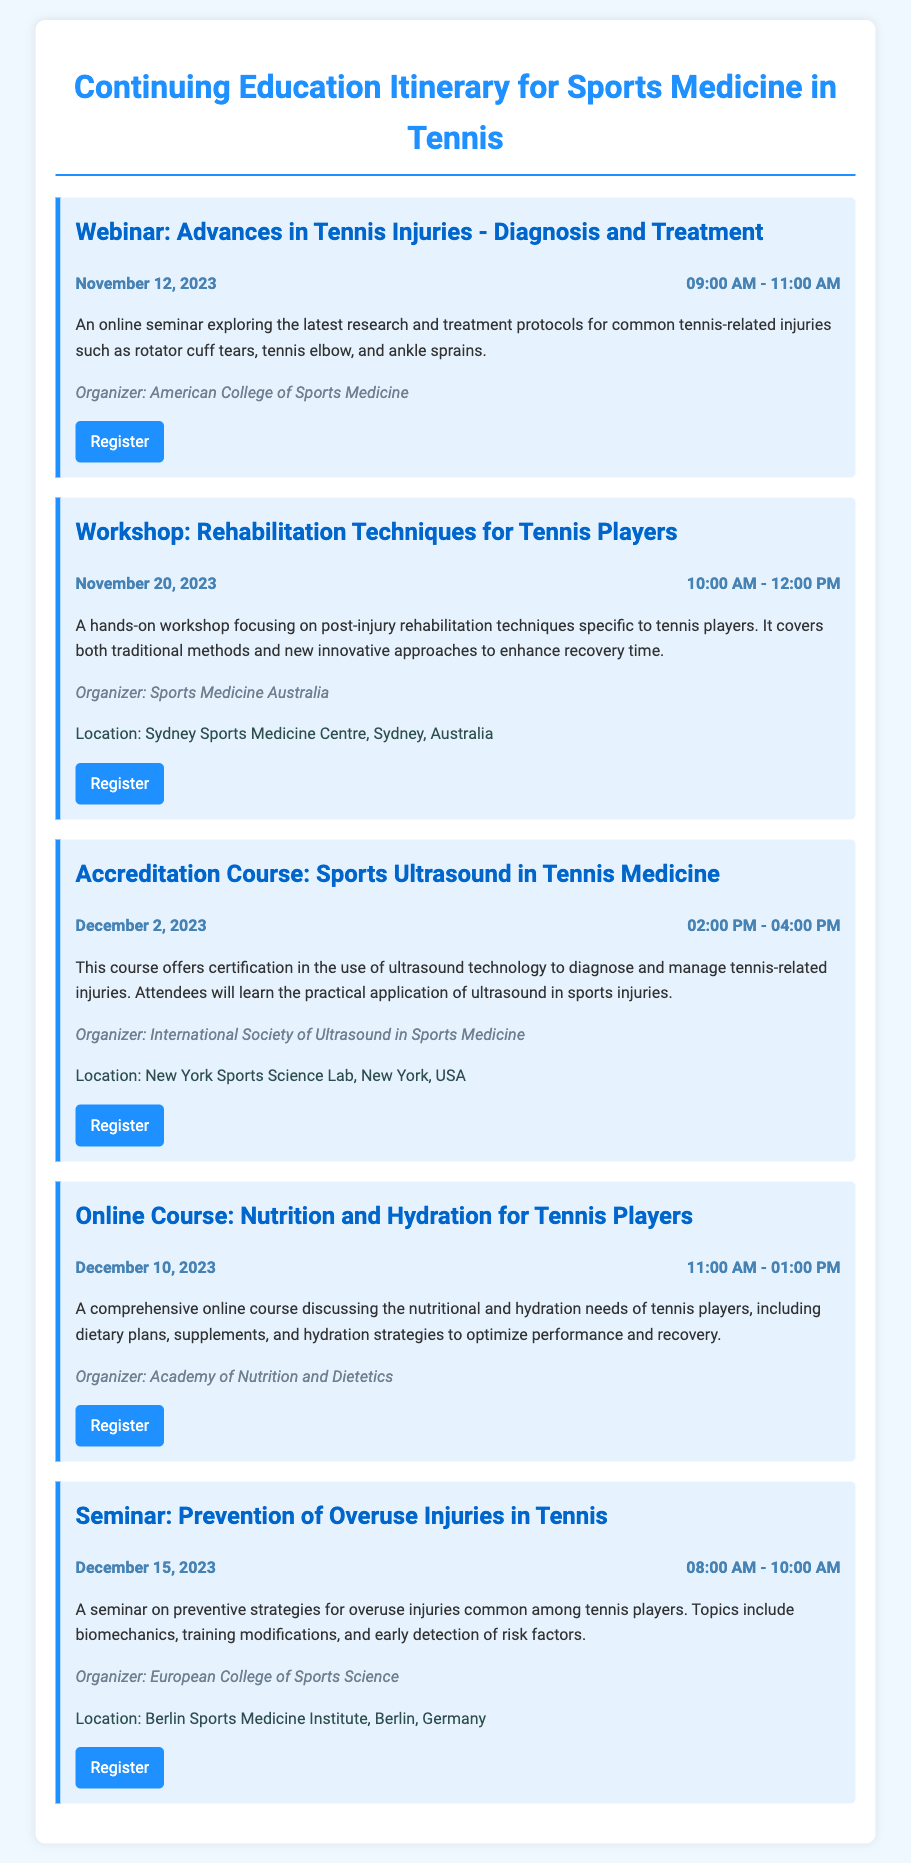What is the date of the webinar on tennis injuries? The date of the webinar is specified in the document as November 12, 2023.
Answer: November 12, 2023 Who is the organizer of the workshop on rehabilitation techniques? The organizer of the workshop is mentioned as Sports Medicine Australia.
Answer: Sports Medicine Australia What time does the accreditation course on sports ultrasound start? The start time for the accreditation course is provided as 02:00 PM.
Answer: 02:00 PM Where is the seminar on overuse injuries held? The location for the seminar is stated as Berlin Sports Medicine Institute, Berlin, Germany.
Answer: Berlin Sports Medicine Institute, Berlin, Germany How long is the online course on nutrition and hydration for tennis players? The duration of the online course is indicated as 2 hours, from 11:00 AM to 01:00 PM.
Answer: 2 hours What type of event is scheduled for December 15, 2023? The type of event is identifiable from the document, which describes it as a seminar.
Answer: Seminar What topic does the webinar cover? The document states that the webinar covers advances in tennis injuries, focusing on diagnosis and treatment.
Answer: Advances in Tennis Injuries - Diagnosis and Treatment Which organization is responsible for the online course on nutrition? The organizer of the online course is named as the Academy of Nutrition and Dietetics.
Answer: Academy of Nutrition and Dietetics What is the focus of the workshop happening on November 20, 2023? The focus of the workshop is specified as rehabilitation techniques for tennis players.
Answer: Rehabilitation Techniques for Tennis Players 